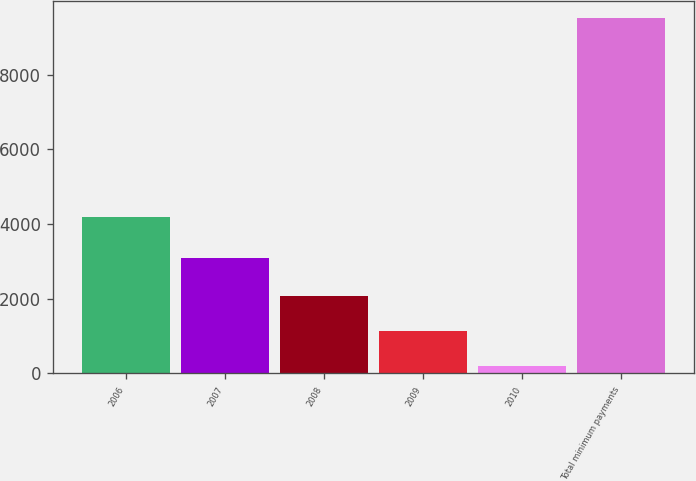Convert chart. <chart><loc_0><loc_0><loc_500><loc_500><bar_chart><fcel>2006<fcel>2007<fcel>2008<fcel>2009<fcel>2010<fcel>Total minimum payments<nl><fcel>4183<fcel>3081<fcel>2056.6<fcel>1125.8<fcel>195<fcel>9503<nl></chart> 